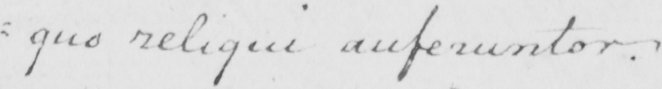What text is written in this handwritten line? =quo reliqui auferuntor . 